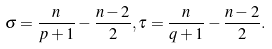Convert formula to latex. <formula><loc_0><loc_0><loc_500><loc_500>\sigma = \frac { n } { p + 1 } - \frac { n - 2 } { 2 } , \tau = \frac { n } { q + 1 } - \frac { n - 2 } { 2 } .</formula> 